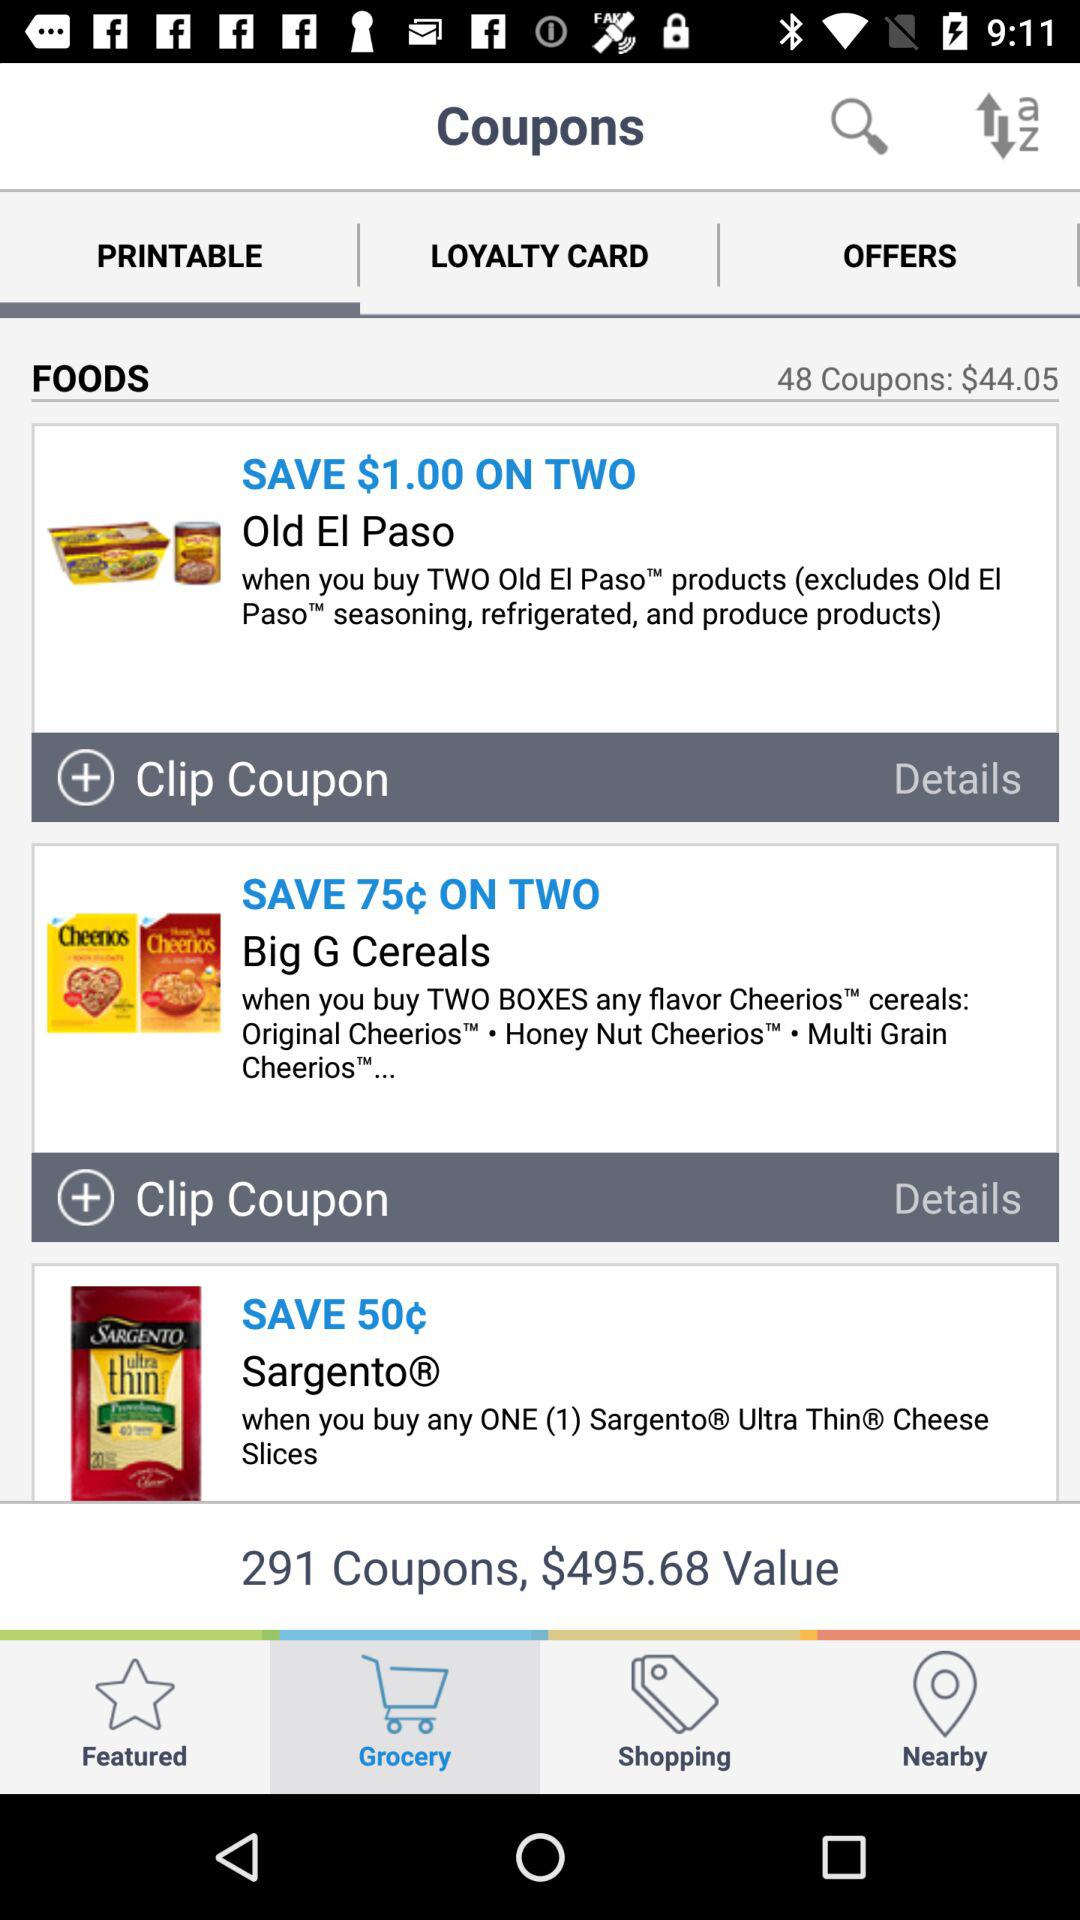What is the value of the coupons? The value of the coupons is $495.68. 